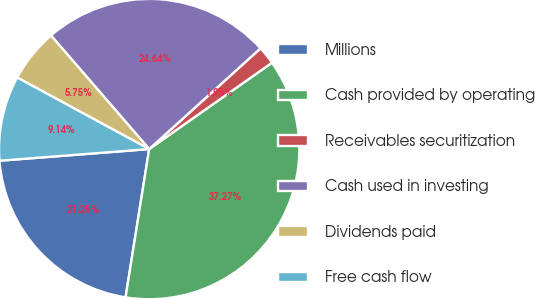Convert chart to OTSL. <chart><loc_0><loc_0><loc_500><loc_500><pie_chart><fcel>Millions<fcel>Cash provided by operating<fcel>Receivables securitization<fcel>Cash used in investing<fcel>Dividends paid<fcel>Free cash flow<nl><fcel>21.25%<fcel>37.27%<fcel>1.95%<fcel>24.64%<fcel>5.75%<fcel>9.14%<nl></chart> 